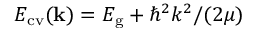<formula> <loc_0><loc_0><loc_500><loc_500>E _ { c v } ( { k } ) = E _ { g } + { \hbar { ^ } { 2 } k ^ { 2 } } / { ( 2 \mu ) }</formula> 